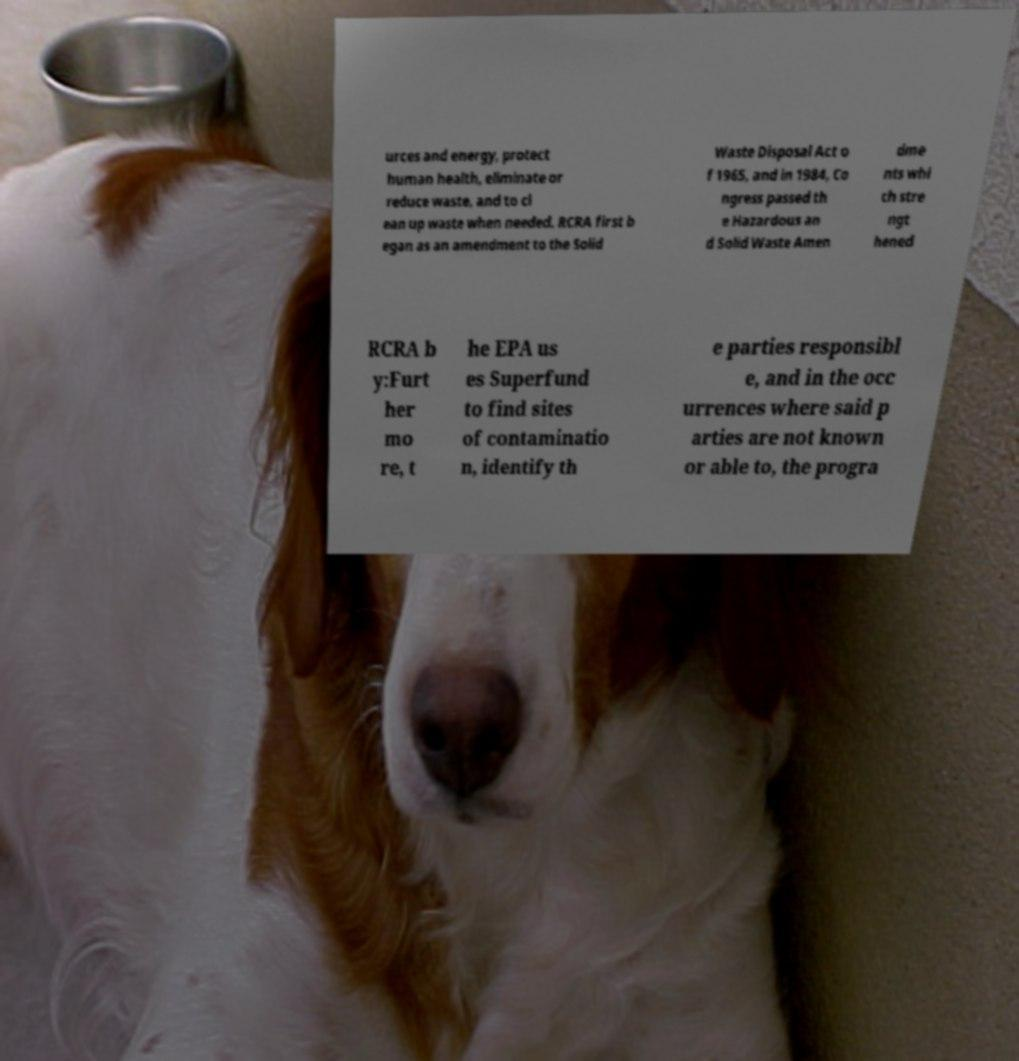Could you extract and type out the text from this image? urces and energy, protect human health, eliminate or reduce waste, and to cl ean up waste when needed. RCRA first b egan as an amendment to the Solid Waste Disposal Act o f 1965, and in 1984, Co ngress passed th e Hazardous an d Solid Waste Amen dme nts whi ch stre ngt hened RCRA b y:Furt her mo re, t he EPA us es Superfund to find sites of contaminatio n, identify th e parties responsibl e, and in the occ urrences where said p arties are not known or able to, the progra 